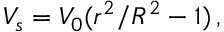Convert formula to latex. <formula><loc_0><loc_0><loc_500><loc_500>V _ { s } = V _ { 0 } ( r ^ { 2 } / R ^ { 2 } - 1 ) \, ,</formula> 